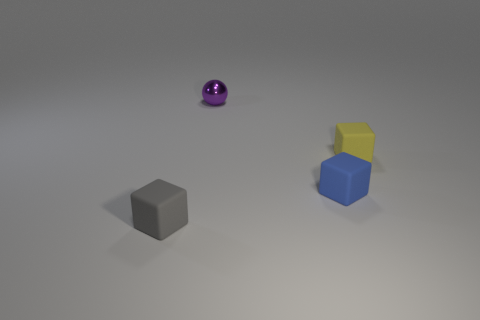Can you describe the lighting and shadows in the scene? The lighting appears to be coming from the upper left, casting subtle shadows directly opposite to it. The shadows are soft-edged, suggesting a diffused light source, possibly indicative of an overcast day or a soft interior light. 